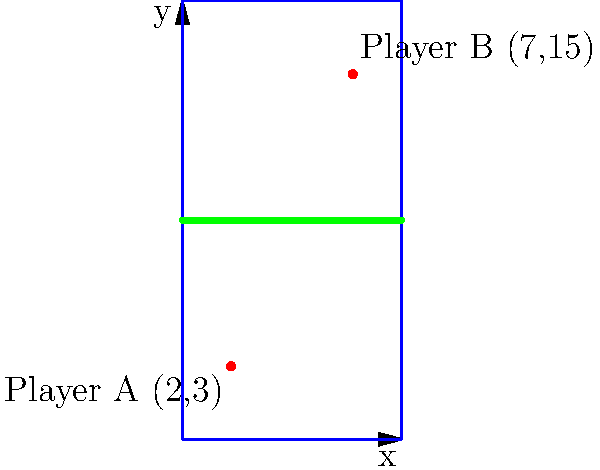In a volleyball match against the Merrimack Warriors, two players from your team are positioned on the court as shown in the diagram. Player A is at coordinates (2,3) and Player B is at coordinates (7,15). Using the distance formula, calculate the distance between these two players to the nearest tenth of a meter. To solve this problem, we'll use the distance formula:

$$d = \sqrt{(x_2 - x_1)^2 + (y_2 - y_1)^2}$$

Where $(x_1, y_1)$ are the coordinates of Player A and $(x_2, y_2)$ are the coordinates of Player B.

Step 1: Identify the coordinates
Player A: $(x_1, y_1) = (2, 3)$
Player B: $(x_2, y_2) = (7, 15)$

Step 2: Plug the values into the distance formula
$$d = \sqrt{(7 - 2)^2 + (15 - 3)^2}$$

Step 3: Simplify the expressions inside the parentheses
$$d = \sqrt{(5)^2 + (12)^2}$$

Step 4: Calculate the squares
$$d = \sqrt{25 + 144}$$

Step 5: Add the values under the square root
$$d = \sqrt{169}$$

Step 6: Calculate the square root
$$d = 13$$

Therefore, the distance between Player A and Player B is 13 meters.
Answer: 13 meters 